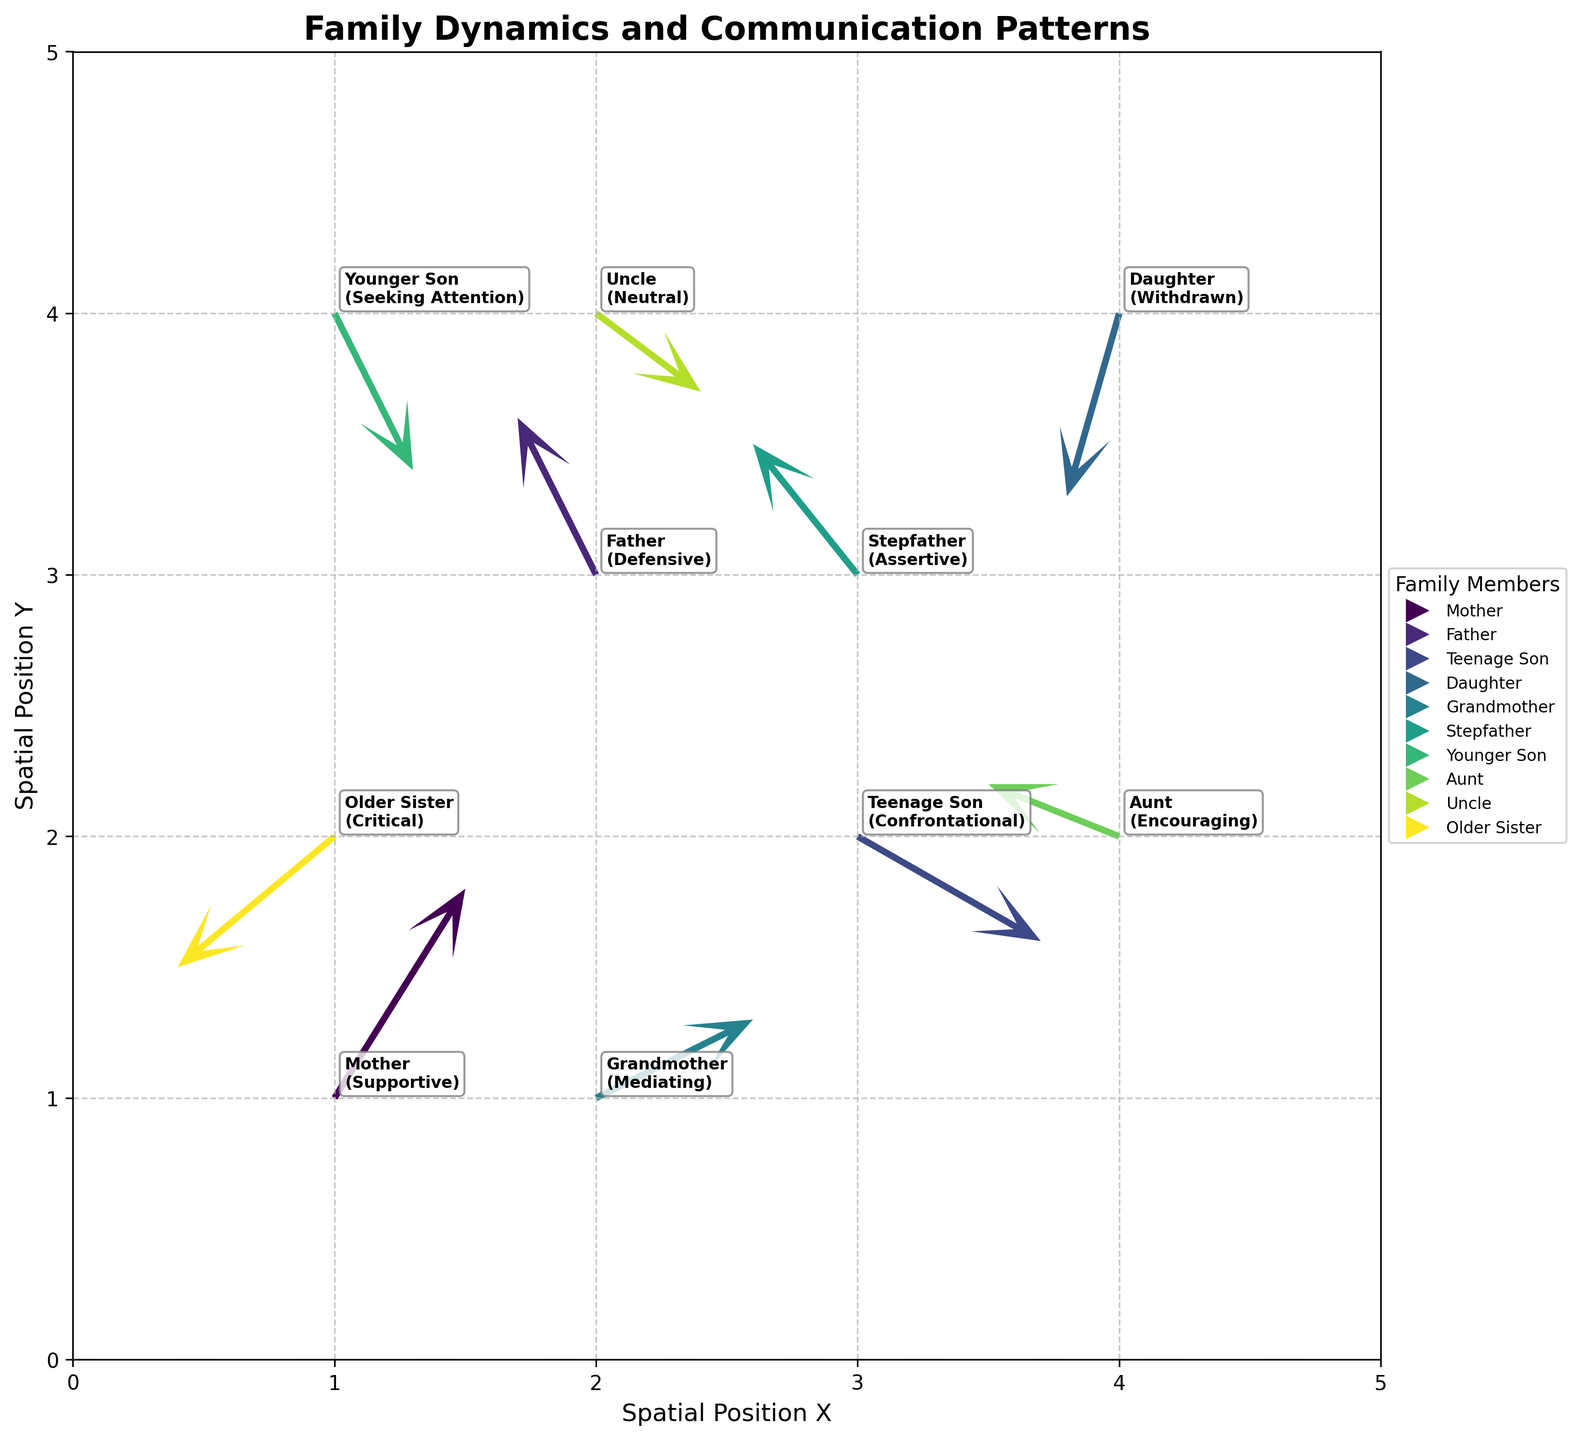What's the title of the plot? The title of the plot is usually found at the top of the figure, typically in a larger or bold font to distinguish it as the heading. In this case, the title is "Family Dynamics and Communication Patterns" as given in the code.
Answer: Family Dynamics and Communication Patterns How many family members are depicted in the plot? To determine the number of family members, count the unique entries in the 'family_member' column of the data table provided. Each row represents a distinct family member involved in the communication patterns, so counting these will give us the total number. There are 10 distinct family members in this data.
Answer: 10 Which family member shows the highest intensity in their interaction, and what is the nature of the interaction? The intensity of an interaction in a Quiver Plot is indicated by the vector lengths, which can be calculated using the Pythagorean theorem, sqrt(u^2 + v^2). By calculating this for each family member, we find the longest vector and identify the family member and interaction type associated with it.
Answer: Mother, Supportive Between the Father and the Stepfather, who has a more defensive interaction type and in which direction is it directed? We need to compare the interaction types of Father and Stepfather. The Father has a defensive interaction type, while the Stepfather is assertive. The vector for the Father has directions of (-0.3, 0.6).
Answer: Father, directed approx. upward-left What direction does the Teenage Son's interaction point, and what is its intensity? The direction of Teenage Son's interaction can be determined by the components of the vector (u=0.7, v=-0.4). The intensity is calculated using sqrt(u^2 + v^2) = sqrt(0.7^2 + (-0.4)^2) ≈ 0.806.
Answer: Downward-right, approximately 0.806 Which two family members have opposing interaction directions and what are those directions? Opposing interactions are indicated by vectors pointing in opposite directions. Evaluating each interaction vector, we notice the Teenage Son (0.7, -0.4, Downward-right) and Older Sister (-0.6, -0.5, Downward-left) have interactions in opposing directions.
Answer: Teenage Son (Downward-right) and Older Sister (Downward-left) If you sum the 'u' and 'v' components of the Grandmother's and Aunt's interactions, what are the resultant interaction components? To find the resultant components, sum the 'u' components of the Grandmother and Aunt, then sum the 'v' components: Grandmother (0.6, 0.3) and Aunt (-0.5, 0.2). So, u resultant = 0.6 - 0.5 = 0.1, and v resultant = 0.3 + 0.2 = 0.5.
Answer: (0.1, 0.5) Which family member's interaction is closest to the origin, and what type of interaction is it? The closest interaction to the origin can be identified by finding the shortest vector magnitude sqrt(x^2 + y^2). Calculating these for all family members, the data point closest to the origin is (1, 1) which belongs to the Mother with a Supportive interaction type.
Answer: Mother, Supportive 